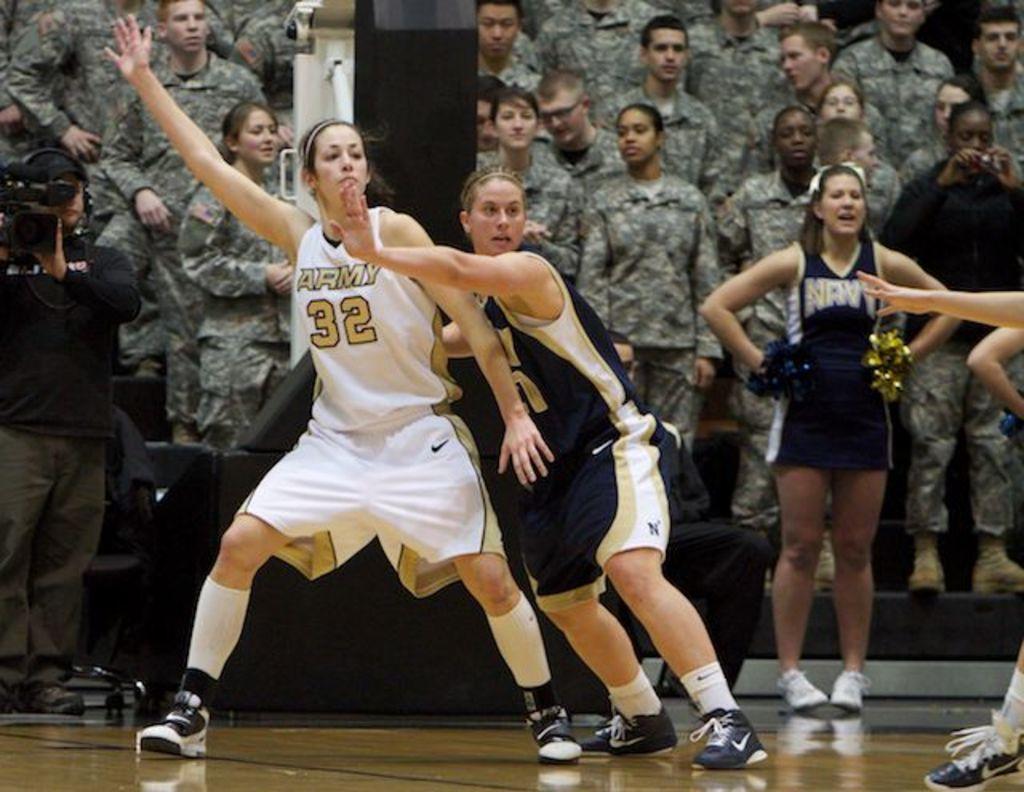What teams are playing?
Make the answer very short. Army and navy. 